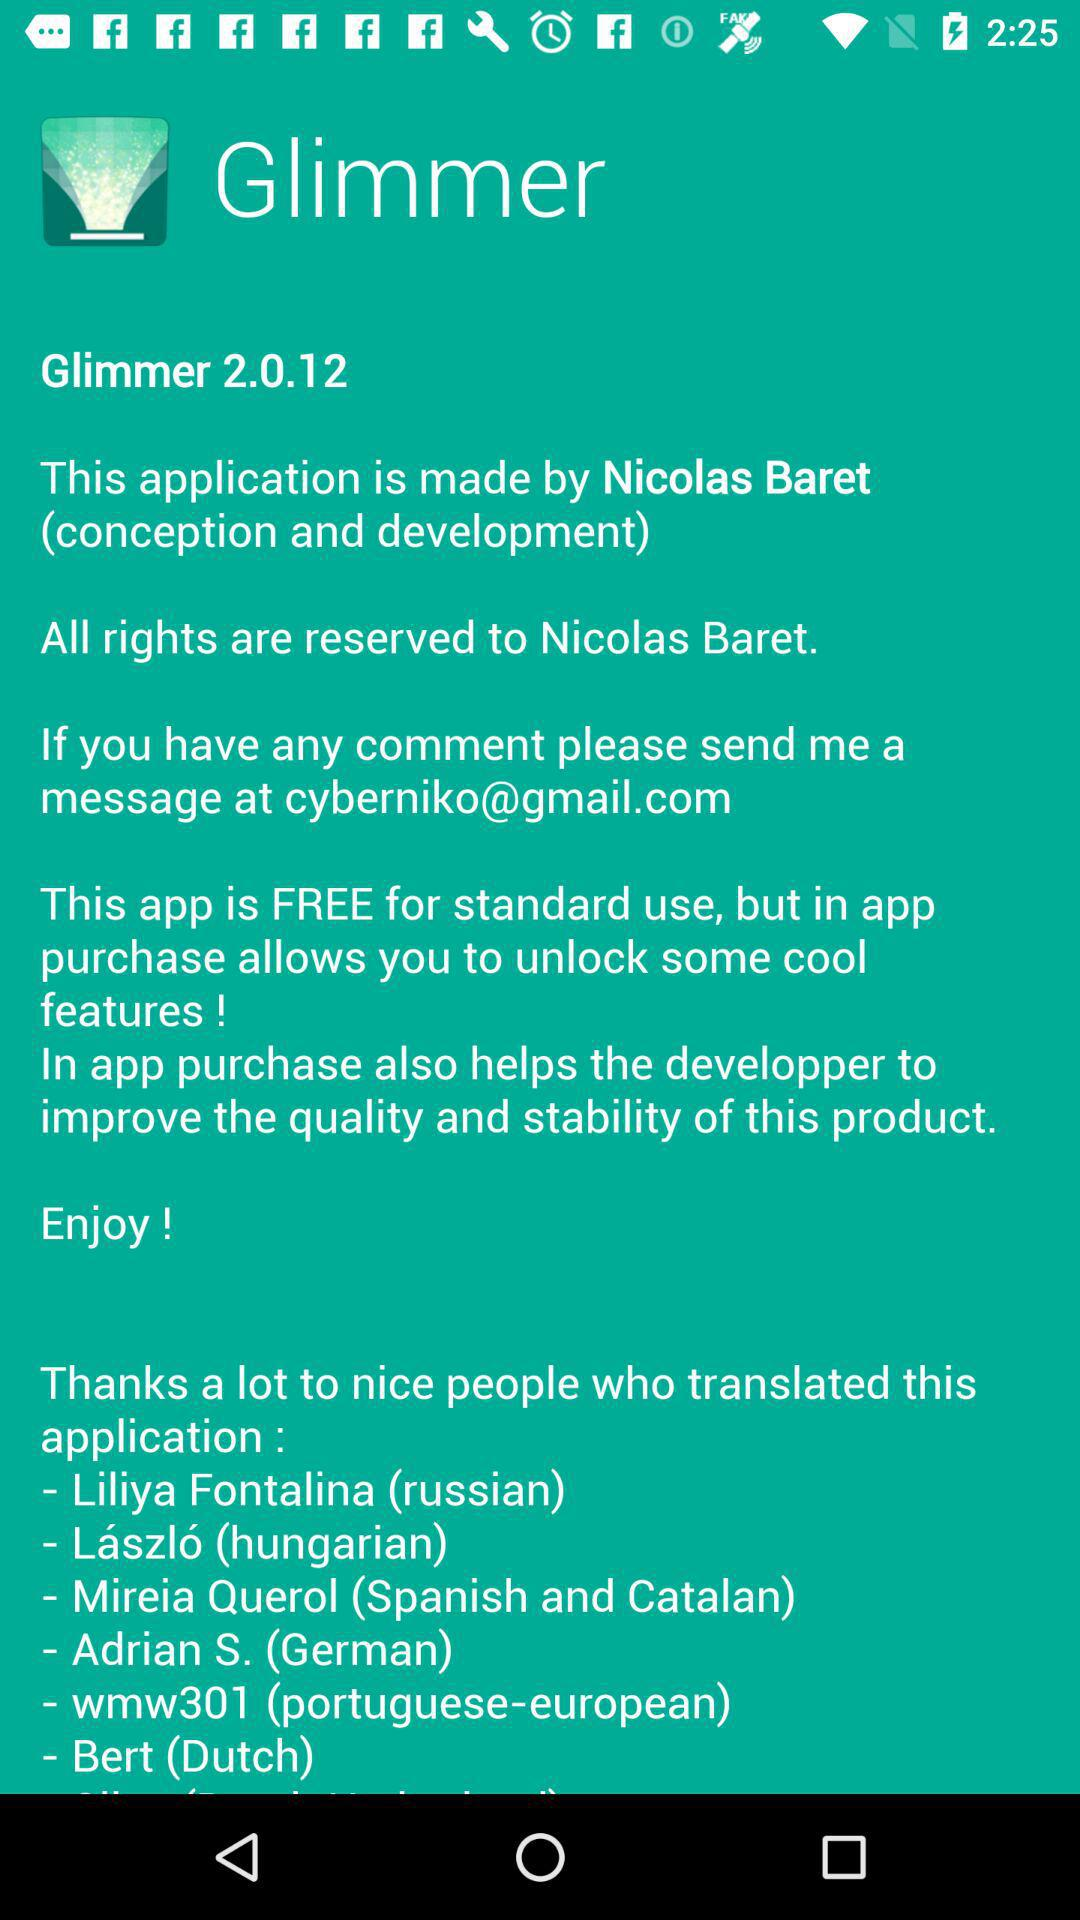How many people translated the app?
Answer the question using a single word or phrase. 6 